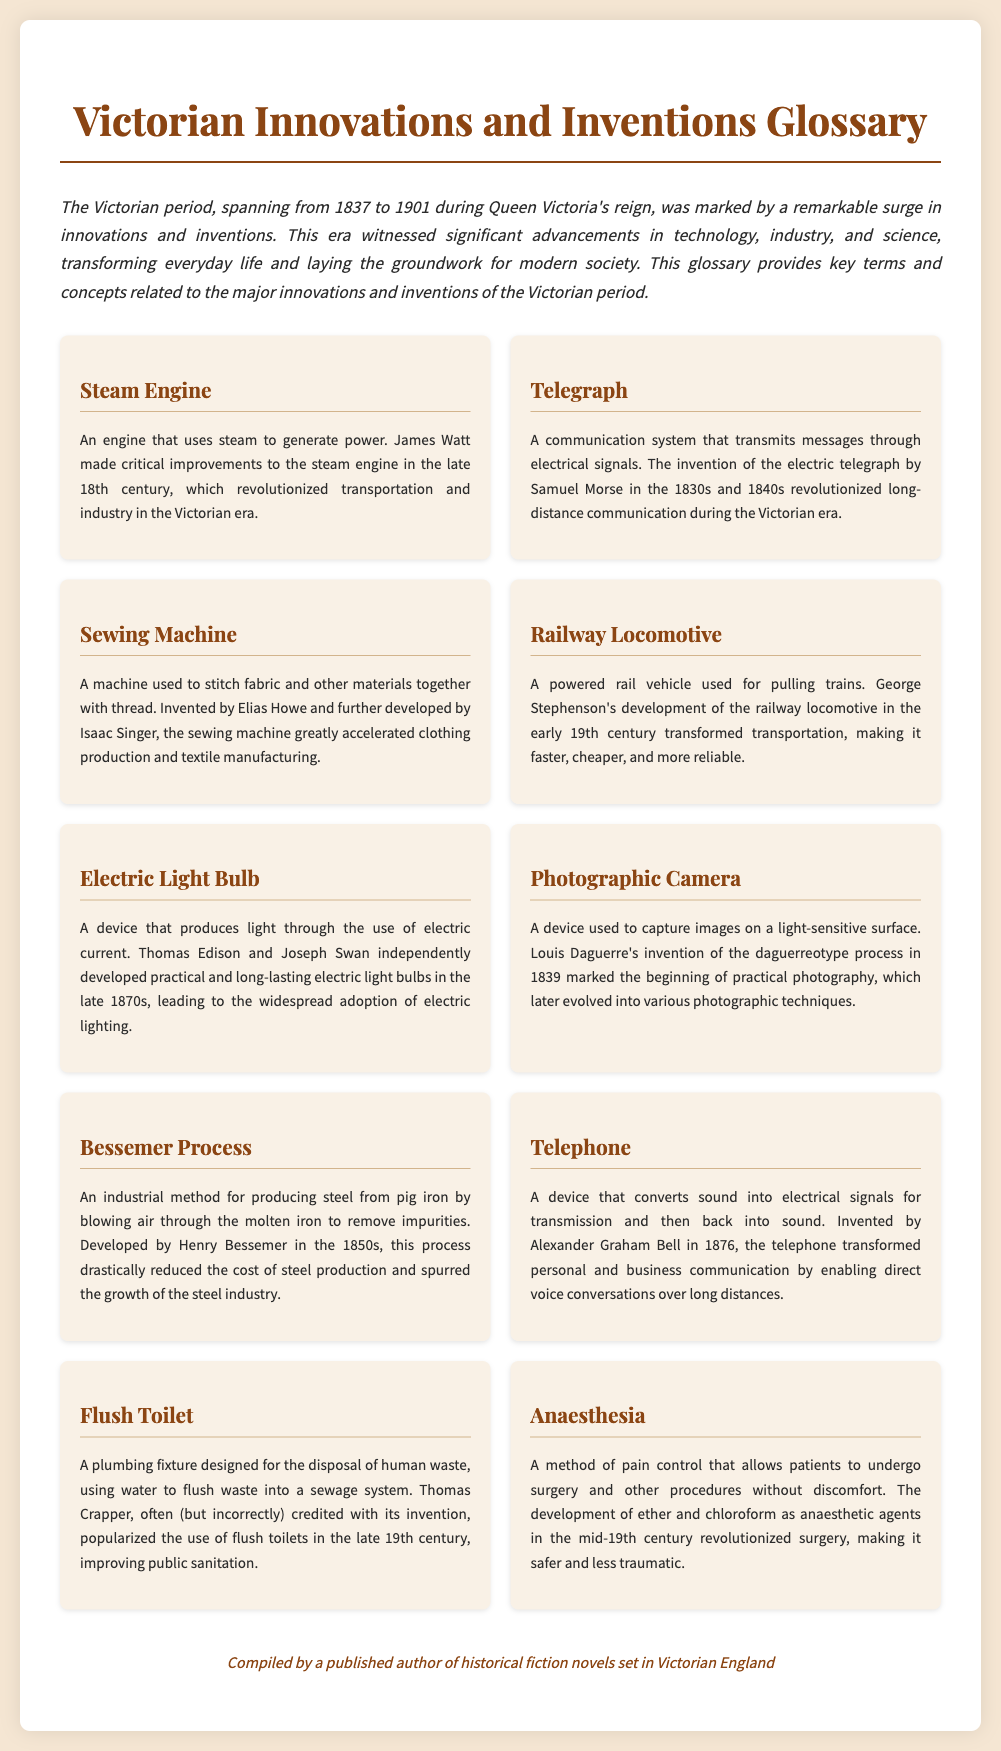what invention does James Watt improve? James Watt made critical improvements to the steam engine, which revolutionized transportation and industry.
Answer: steam engine who invented the electric telegraph? The electric telegraph was invented by Samuel Morse in the 1830s and 1840s.
Answer: Samuel Morse what major invention did Elias Howe contribute to? Elias Howe invented the sewing machine, which drastically increased clothing production.
Answer: sewing machine in what year was the telephone invented? The telephone was invented by Alexander Graham Bell in 1876.
Answer: 1876 who popularized the flush toilet? Thomas Crapper is often credited with popularizing the flush toilet in the late 19th century.
Answer: Thomas Crapper what process did Henry Bessemer develop? Henry Bessemer developed the Bessemer process for producing steel from pig iron.
Answer: Bessemer process what revolutionized surgery in the mid-19th century? The development of ether and chloroform as anaesthetic agents revolutionized surgery.
Answer: anaesthesia which invention allowed for capturing images on a light-sensitive surface? The photographic camera allowed for capturing images on a light-sensitive surface, first developed in the form of the daguerreotype.
Answer: photographic camera 